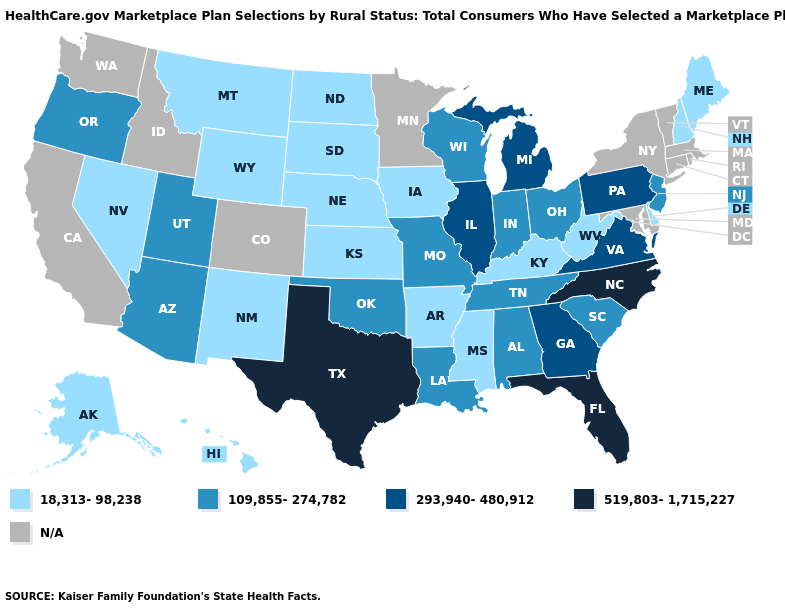What is the highest value in the USA?
Short answer required. 519,803-1,715,227. Name the states that have a value in the range 109,855-274,782?
Be succinct. Alabama, Arizona, Indiana, Louisiana, Missouri, New Jersey, Ohio, Oklahoma, Oregon, South Carolina, Tennessee, Utah, Wisconsin. What is the lowest value in the USA?
Keep it brief. 18,313-98,238. Does the map have missing data?
Give a very brief answer. Yes. What is the value of Pennsylvania?
Concise answer only. 293,940-480,912. Does Illinois have the highest value in the MidWest?
Short answer required. Yes. Does the first symbol in the legend represent the smallest category?
Give a very brief answer. Yes. Name the states that have a value in the range 18,313-98,238?
Short answer required. Alaska, Arkansas, Delaware, Hawaii, Iowa, Kansas, Kentucky, Maine, Mississippi, Montana, Nebraska, Nevada, New Hampshire, New Mexico, North Dakota, South Dakota, West Virginia, Wyoming. Does the map have missing data?
Give a very brief answer. Yes. What is the highest value in states that border Wisconsin?
Answer briefly. 293,940-480,912. Name the states that have a value in the range 519,803-1,715,227?
Concise answer only. Florida, North Carolina, Texas. Name the states that have a value in the range N/A?
Short answer required. California, Colorado, Connecticut, Idaho, Maryland, Massachusetts, Minnesota, New York, Rhode Island, Vermont, Washington. How many symbols are there in the legend?
Write a very short answer. 5. Name the states that have a value in the range 109,855-274,782?
Answer briefly. Alabama, Arizona, Indiana, Louisiana, Missouri, New Jersey, Ohio, Oklahoma, Oregon, South Carolina, Tennessee, Utah, Wisconsin. What is the value of North Carolina?
Write a very short answer. 519,803-1,715,227. 